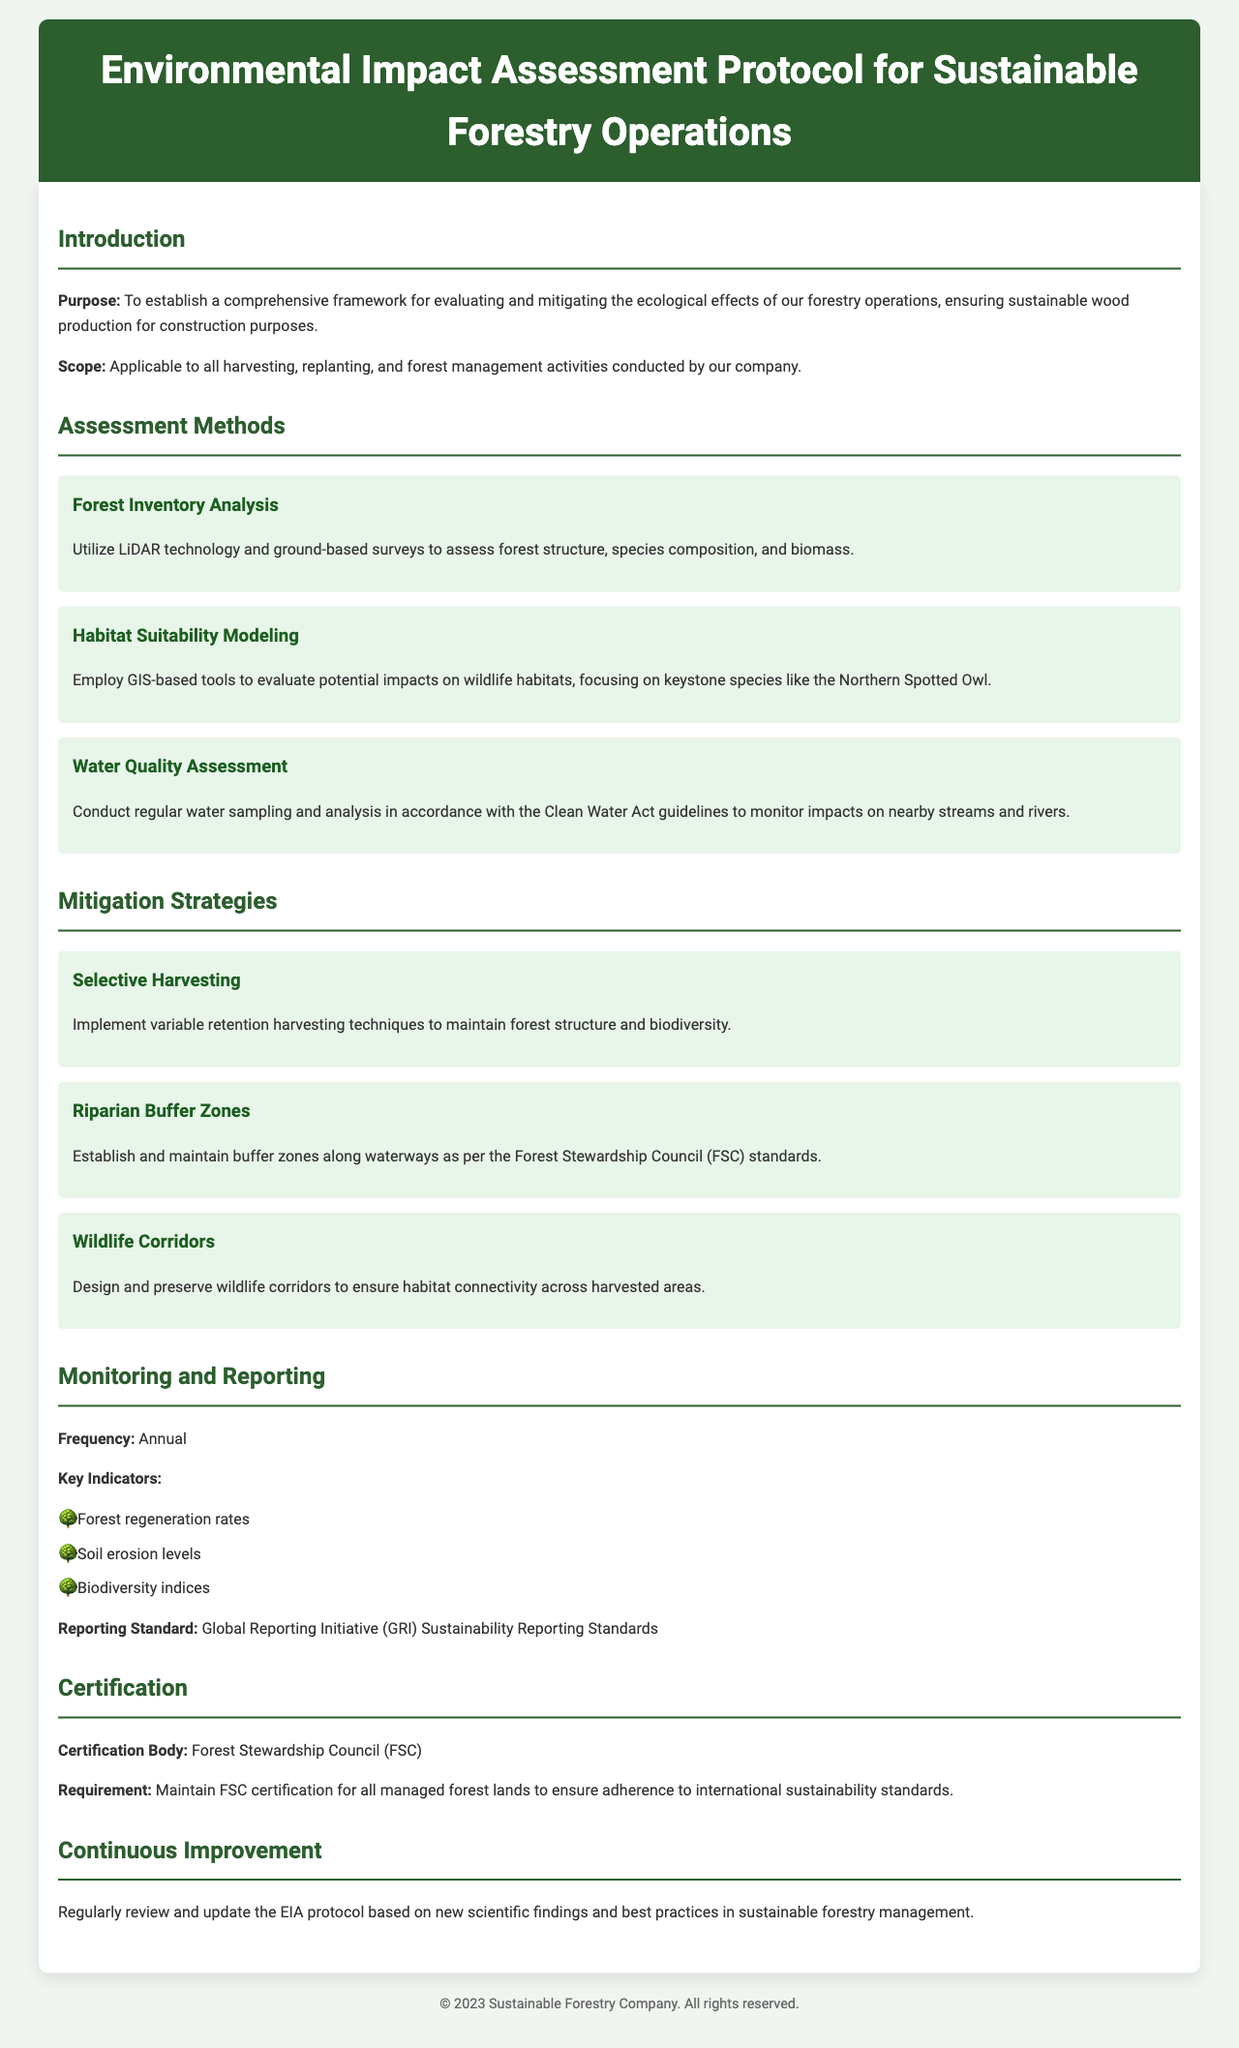what is the purpose of the document? The purpose is to establish a comprehensive framework for evaluating and mitigating the ecological effects of forestry operations.
Answer: comprehensive framework which assessment method uses LiDAR technology? The method that utilizes LiDAR technology is Forest Inventory Analysis.
Answer: Forest Inventory Analysis what are the key indicators for monitoring? The key indicators for monitoring include forest regeneration rates, soil erosion levels, and biodiversity indices.
Answer: forest regeneration rates, soil erosion levels, biodiversity indices how frequently is monitoring conducted? The document states that monitoring is conducted annually.
Answer: annual what certification body does the document mention? The certification body mentioned in the document is the Forest Stewardship Council (FSC).
Answer: Forest Stewardship Council (FSC) name one mitigation strategy outlined in the document. One mitigation strategy outlined is Selective Harvesting.
Answer: Selective Harvesting what does the document say about continuous improvement? It states that the EIA protocol should be regularly reviewed and updated based on new scientific findings.
Answer: regularly review and update what is the reporting standard mentioned? The reporting standard mentioned is the Global Reporting Initiative (GRI) Sustainability Reporting Standards.
Answer: Global Reporting Initiative (GRI) Sustainability Reporting Standards which keystone species is focused on in habitat suitability modeling? The keystone species focused on is the Northern Spotted Owl.
Answer: Northern Spotted Owl 